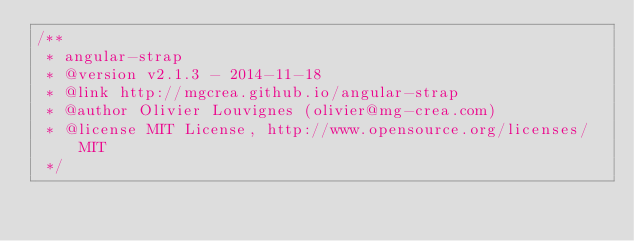Convert code to text. <code><loc_0><loc_0><loc_500><loc_500><_JavaScript_>/**
 * angular-strap
 * @version v2.1.3 - 2014-11-18
 * @link http://mgcrea.github.io/angular-strap
 * @author Olivier Louvignes (olivier@mg-crea.com)
 * @license MIT License, http://www.opensource.org/licenses/MIT
 */</code> 